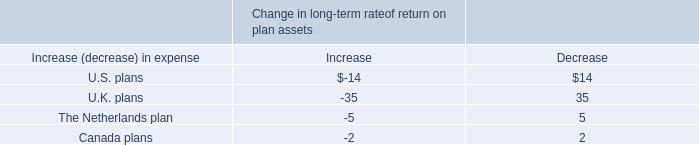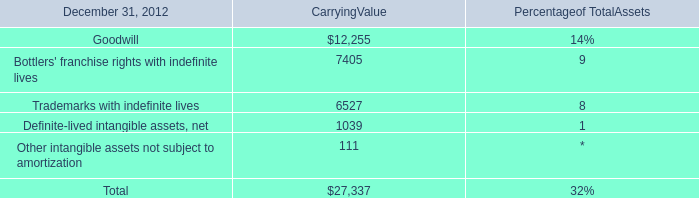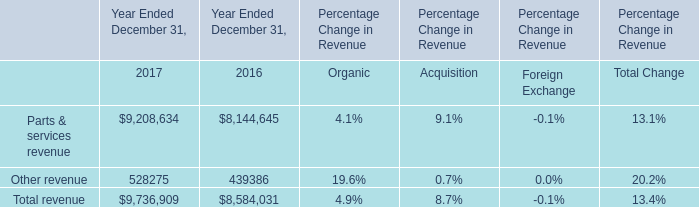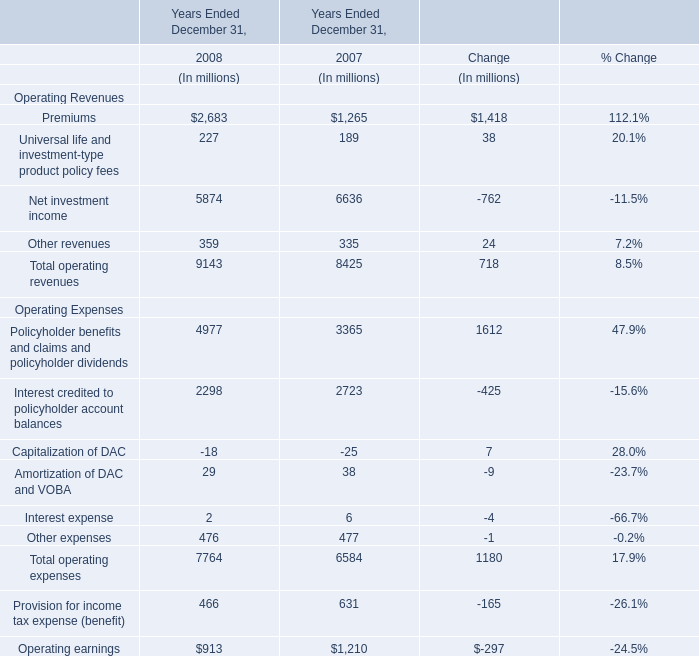What is the percentage of all Operating Revenues that is positive to the total operating revenues, in 2008? (in %) 
Computations: ((((2683 + 227) + 5874) + 359) / 9143)
Answer: 1.0. 